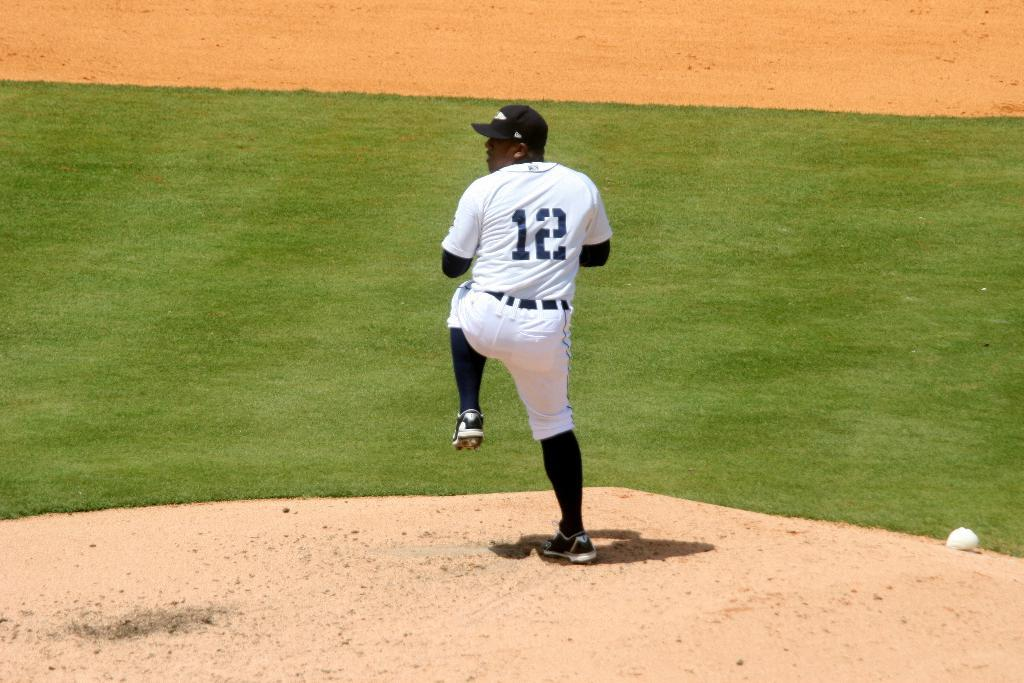<image>
Present a compact description of the photo's key features. a baseball player wearing the white uniform number 12 